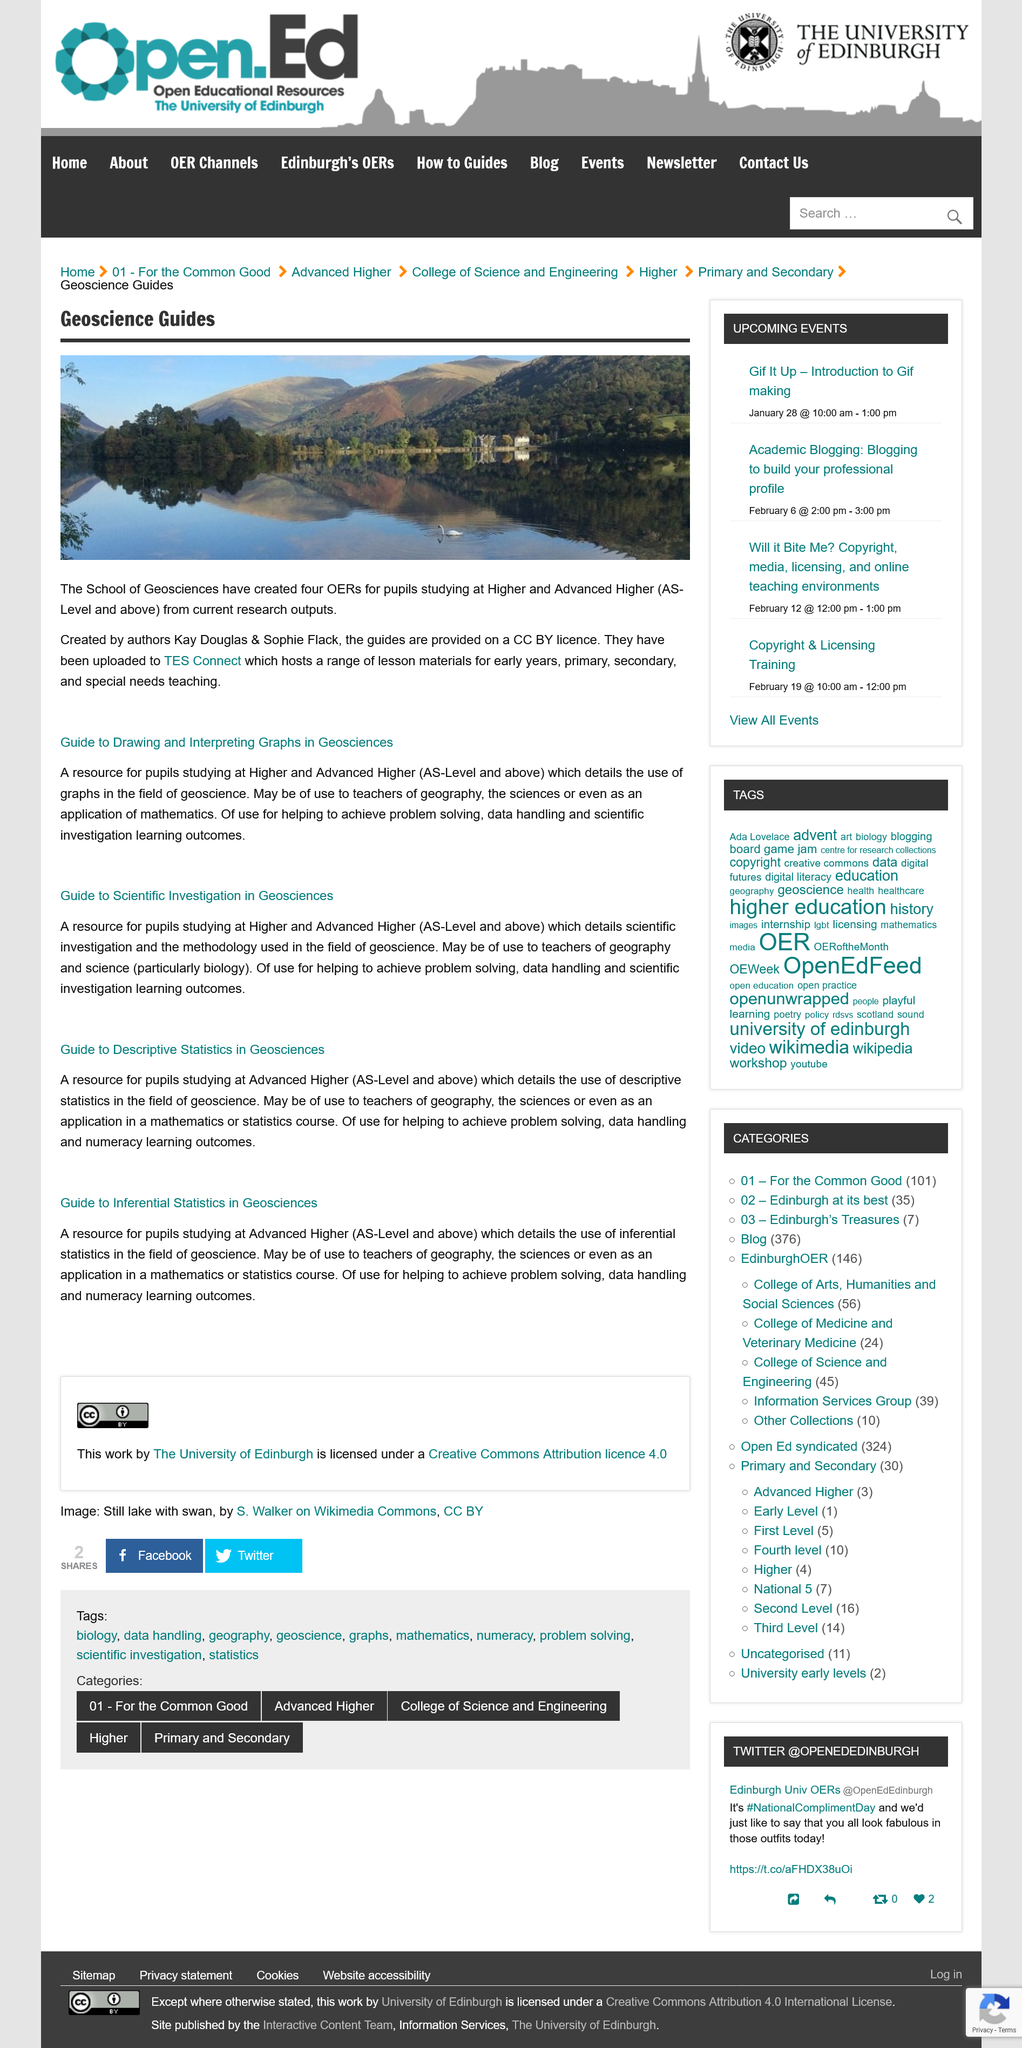Draw attention to some important aspects in this diagram. Yes, the guides are designed specifically for pupils studying at Advanced Higher level. The authors Kay Douglas and Sophie Flack created the four OERs for the School of Geosciences. The provided guides are effective in achieving data handling outcomes. The school of Geoscience has created four OERs that are specifically designed for pupils studying at Higher and Advanced Higher levels. The 'guide to drawing and interpreting graphs in Geosciences' is a comprehensive resource for pupils that provides a detailed explanation of the use of graphs in the field of geoscience. 